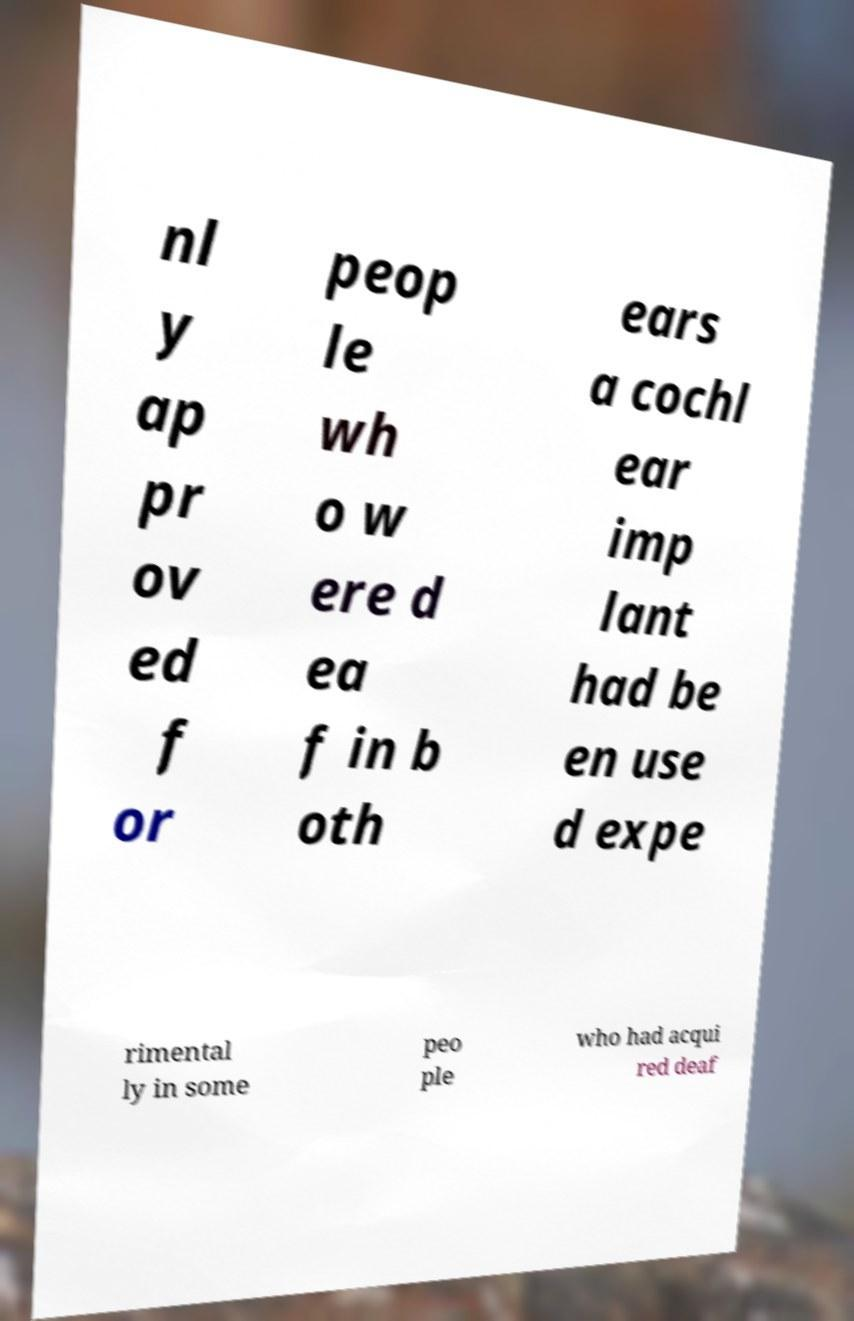Please read and relay the text visible in this image. What does it say? nl y ap pr ov ed f or peop le wh o w ere d ea f in b oth ears a cochl ear imp lant had be en use d expe rimental ly in some peo ple who had acqui red deaf 